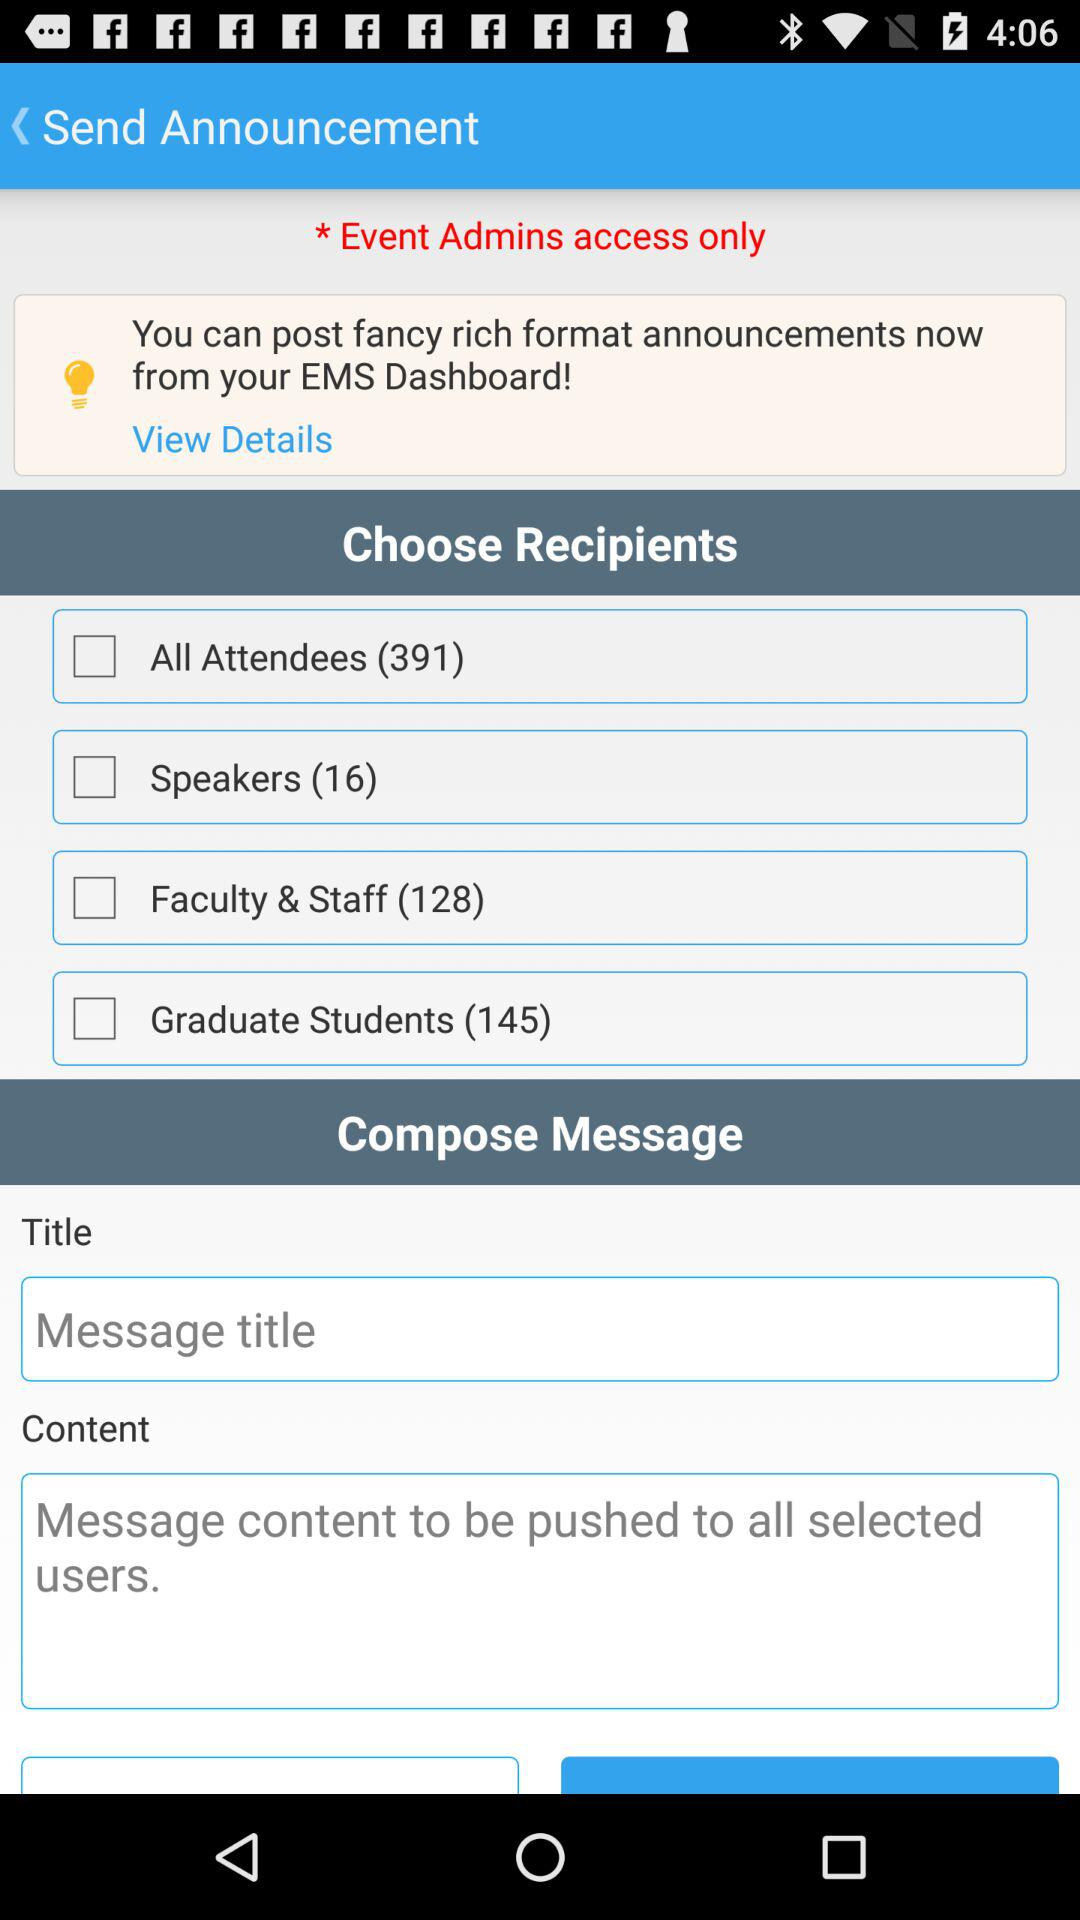How many people are there in "Speakers"? There are 16 people. 